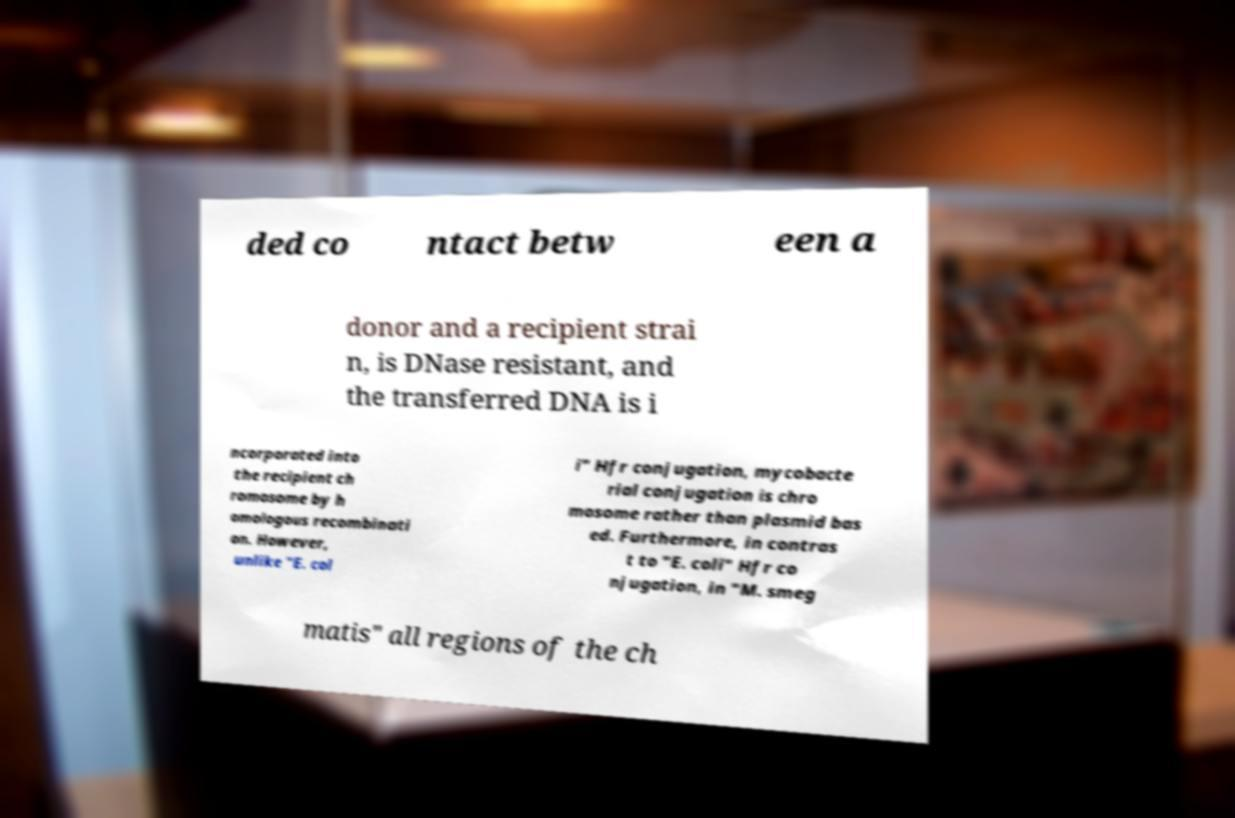What messages or text are displayed in this image? I need them in a readable, typed format. ded co ntact betw een a donor and a recipient strai n, is DNase resistant, and the transferred DNA is i ncorporated into the recipient ch romosome by h omologous recombinati on. However, unlike "E. col i" Hfr conjugation, mycobacte rial conjugation is chro mosome rather than plasmid bas ed. Furthermore, in contras t to "E. coli" Hfr co njugation, in "M. smeg matis" all regions of the ch 